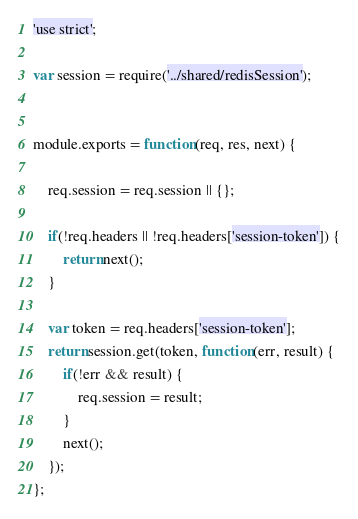Convert code to text. <code><loc_0><loc_0><loc_500><loc_500><_JavaScript_>'use strict';

var session = require('../shared/redisSession');


module.exports = function(req, res, next) {

    req.session = req.session || {};

    if(!req.headers || !req.headers['session-token']) {
        return next();
    }

    var token = req.headers['session-token'];
    return session.get(token, function(err, result) {
        if(!err && result) {
            req.session = result;
        }
        next();
    });
};</code> 